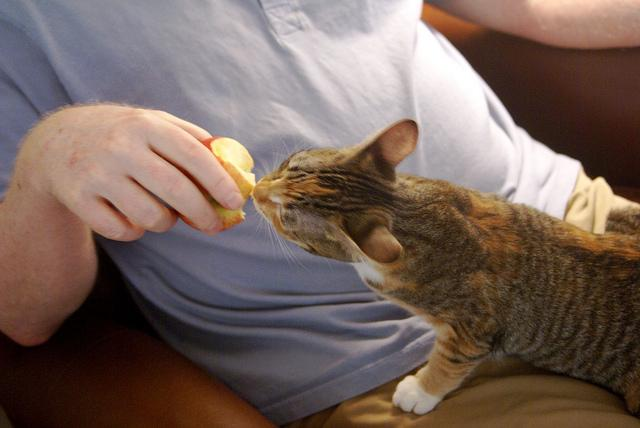Where do apples originate from? Please explain your reasoning. asia. Apples first came from kazakhstan which is in central asia. 